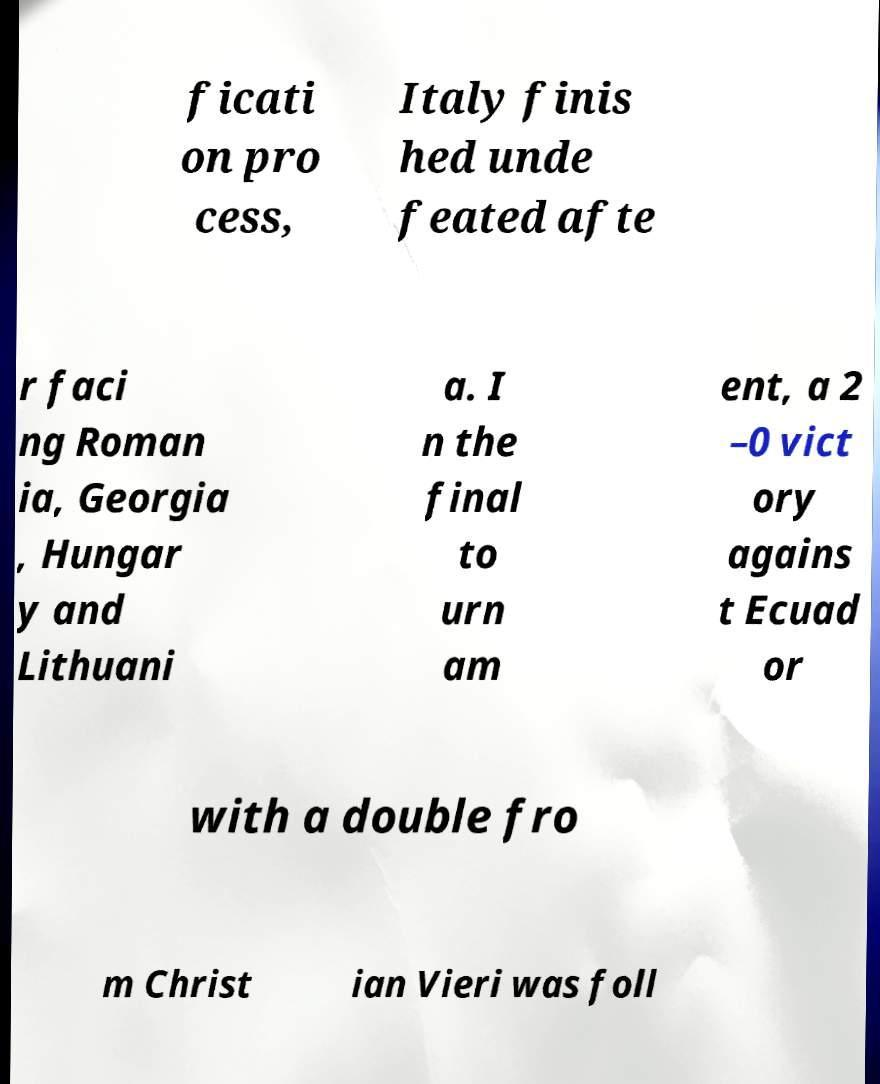There's text embedded in this image that I need extracted. Can you transcribe it verbatim? ficati on pro cess, Italy finis hed unde feated afte r faci ng Roman ia, Georgia , Hungar y and Lithuani a. I n the final to urn am ent, a 2 –0 vict ory agains t Ecuad or with a double fro m Christ ian Vieri was foll 